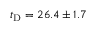Convert formula to latex. <formula><loc_0><loc_0><loc_500><loc_500>t _ { D } = 2 6 . 4 \pm 1 . 7</formula> 